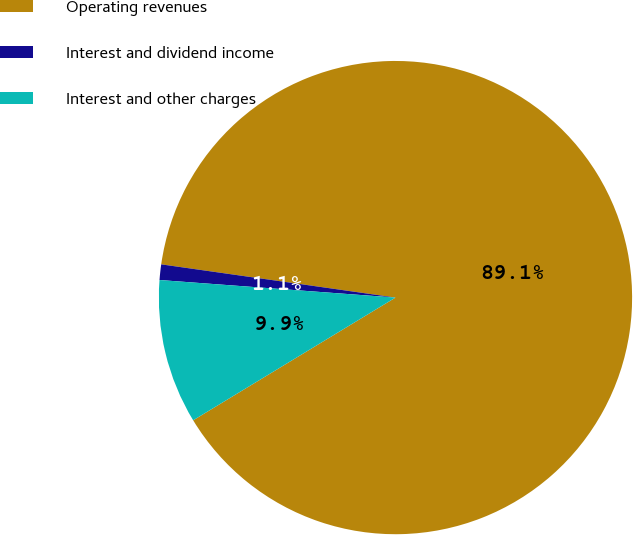Convert chart to OTSL. <chart><loc_0><loc_0><loc_500><loc_500><pie_chart><fcel>Operating revenues<fcel>Interest and dividend income<fcel>Interest and other charges<nl><fcel>89.08%<fcel>1.06%<fcel>9.86%<nl></chart> 